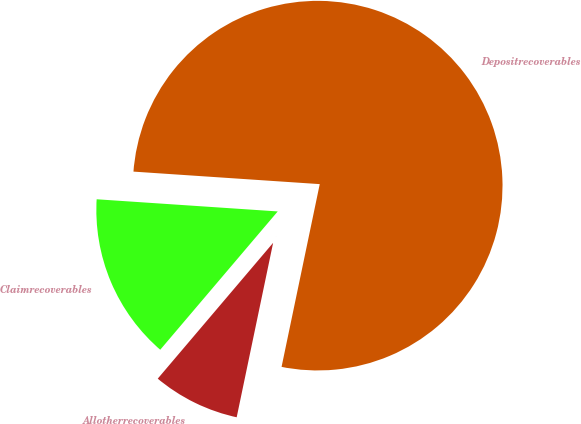<chart> <loc_0><loc_0><loc_500><loc_500><pie_chart><fcel>Depositrecoverables<fcel>Claimrecoverables<fcel>Allotherrecoverables<nl><fcel>77.21%<fcel>14.86%<fcel>7.93%<nl></chart> 